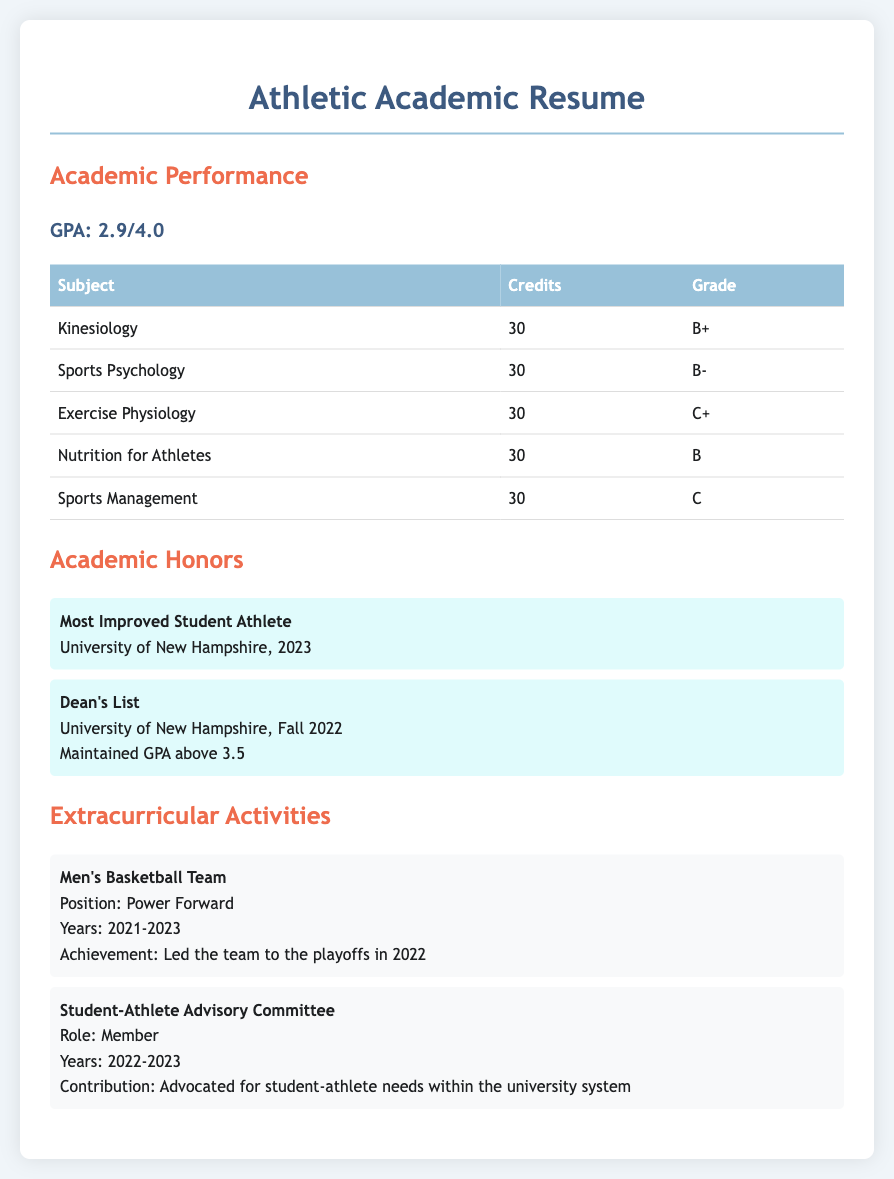What is your GPA? The GPA is mentioned directly in the academic performance section of the document, which states 2.9/4.0.
Answer: 2.9/4.0 What is your major subject? The document highlights multiple subjects related to a major in Kinesiology and associated fields, indicating the focus area.
Answer: Kinesiology How many credits did you earn for Nutrition for Athletes? The document specifies the credits for each subject, showing that Nutrition for Athletes has 30 credits.
Answer: 30 What grade did you achieve in Exercise Physiology? The grade is provided in the table of subjects, where Exercise Physiology has a grade of C+.
Answer: C+ When was the last time you made the Dean's List? The academic honors section notes that the most recent Dean's List recognition was in Fall 2022.
Answer: Fall 2022 What was one academic honor you received in 2023? The document lists the Most Improved Student Athlete award received in 2023 as an academic honor.
Answer: Most Improved Student Athlete Which team did you play for in college? The extracurricular activities section specifies that you played for the Men's Basketball Team.
Answer: Men's Basketball Team What position did you play on the basketball team? The document clearly states that the position held on the basketball team was Power Forward.
Answer: Power Forward How many subjects are listed in the Academic Performance section? By counting the entries in the subjects table, it is clear that there are five subjects listed.
Answer: 5 